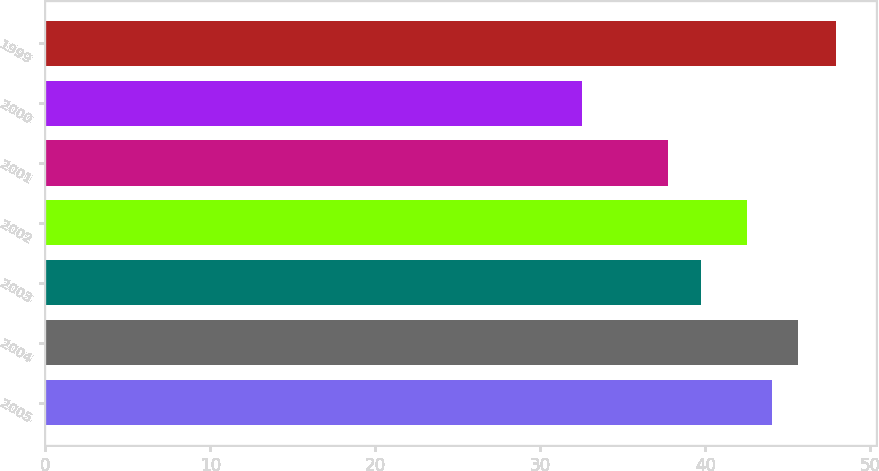Convert chart. <chart><loc_0><loc_0><loc_500><loc_500><bar_chart><fcel>2005<fcel>2004<fcel>2003<fcel>2002<fcel>2001<fcel>2000<fcel>1999<nl><fcel>44.05<fcel>45.59<fcel>39.72<fcel>42.51<fcel>37.75<fcel>32.5<fcel>47.94<nl></chart> 